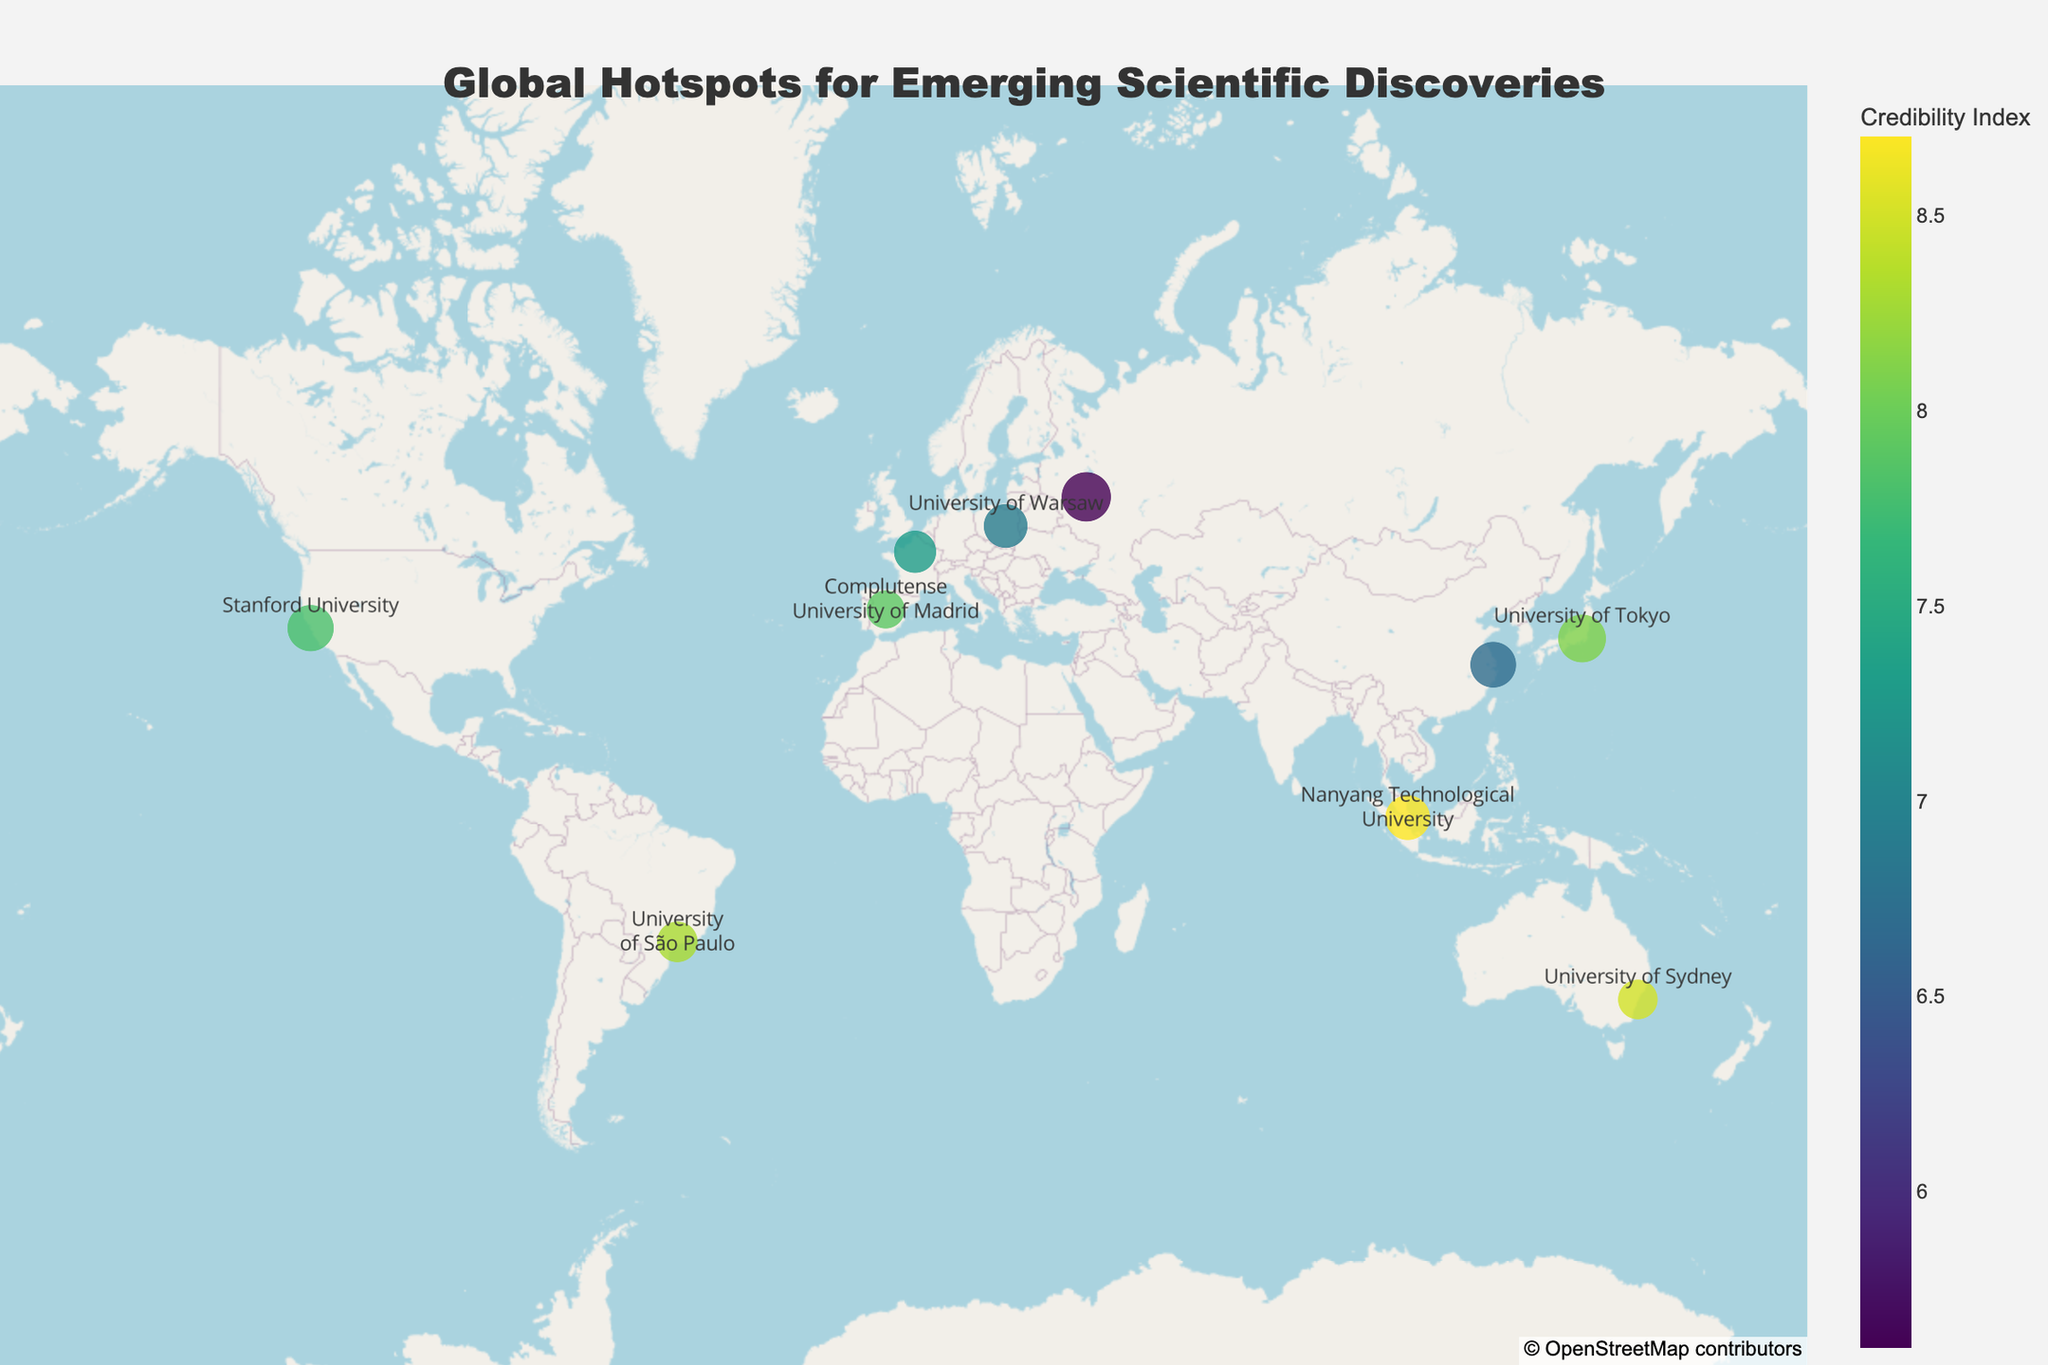What is the title of the geographic plot? The title is typically located at the top of the figure. Here, it is written in the center above the plot. It reads, "Global Hotspots for Emerging Scientific Discoveries."
Answer: Global Hotspots for Emerging Scientific Discoveries How many institutions are shown on the map? By counting the points or markers on the map, you can determine the number of institutions represented. Each marker corresponds to an institution.
Answer: 10 Which institution has the highest Breakthrough Score? The map shows markers of different sizes, representing Breakthrough Scores. The largest marker corresponds to Moscow State University. By checking the hover text on the plot, it's confirmed.
Answer: Moscow State University What is the range of the Credibility Index values? The color bar represents the Credibility Index. Observing the extreme values on the color scale bar on the right can indicate the range.
Answer: 5.6 to 8.7 Which institution both has a high Breakthrough Score and a high Credibility Index? To determine this, look for a relatively large marker with a color indicating a high Credibility Index. Nanyang Technological University stands out with both high values.
Answer: Nanyang Technological University What discovery is associated with Fudan University? Hovering over the marker for Fudan University will display a text box with the discovery mentioned. It states "Superconductor Discovery."
Answer: Superconductor Discovery Which institution has the lowest Credibility Index, and what is the associated discovery? Observing the color scale for the darkest marker and verifying with the hover text, Moscow State University has the lowest Credibility Index and is associated with "Space-Time Manipulation."
Answer: Moscow State University, Space-Time Manipulation Compare the Breakthrough Scores of Stanford University and University of Tokyo. Which one is higher? By looking at the sizes of the markers for both institutions and verifying their hover text, it is clear that University of Tokyo has a higher Breakthrough Score than Stanford University.
Answer: University of Tokyo Calculate the average Credibility Index of all institutions. Sum the Credibility Index values: 7.8 + 6.9 + 8.5 + 8.1 + 7.3 + 5.6 + 8.7 + 7.9 + 8.3 + 6.7 = 75.8. Divide by the number of institutions: 75.8 / 10 = 7.58.
Answer: 7.58 Identify the institution located closest to the equator. The equator is at latitude 0. The institution with the latitude closest to 0 is Nanyang Technological University at 1.3521.
Answer: Nanyang Technological University 